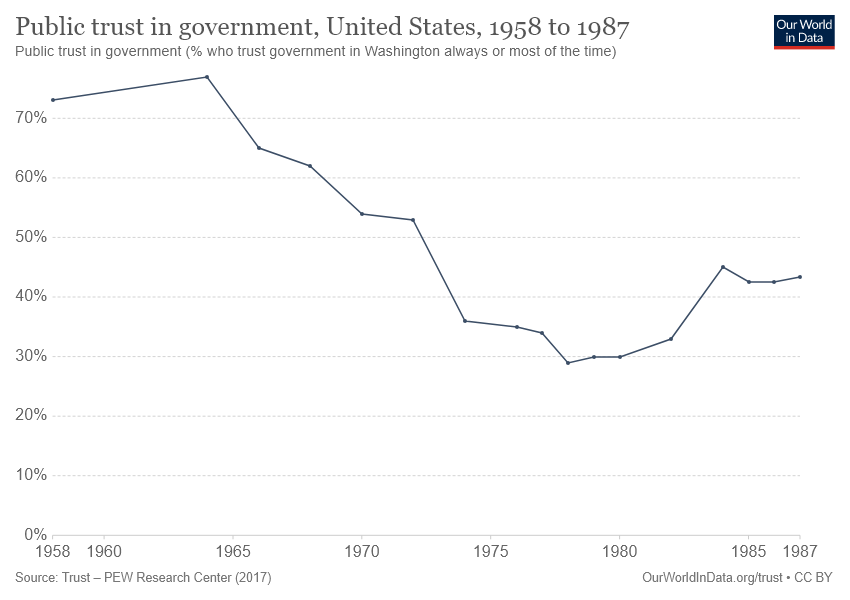Identify some key points in this picture. In the year [1975, 1980], the public trust in government was at its lowest. The public trust in government was more than 50% between 1958 and 1972. 